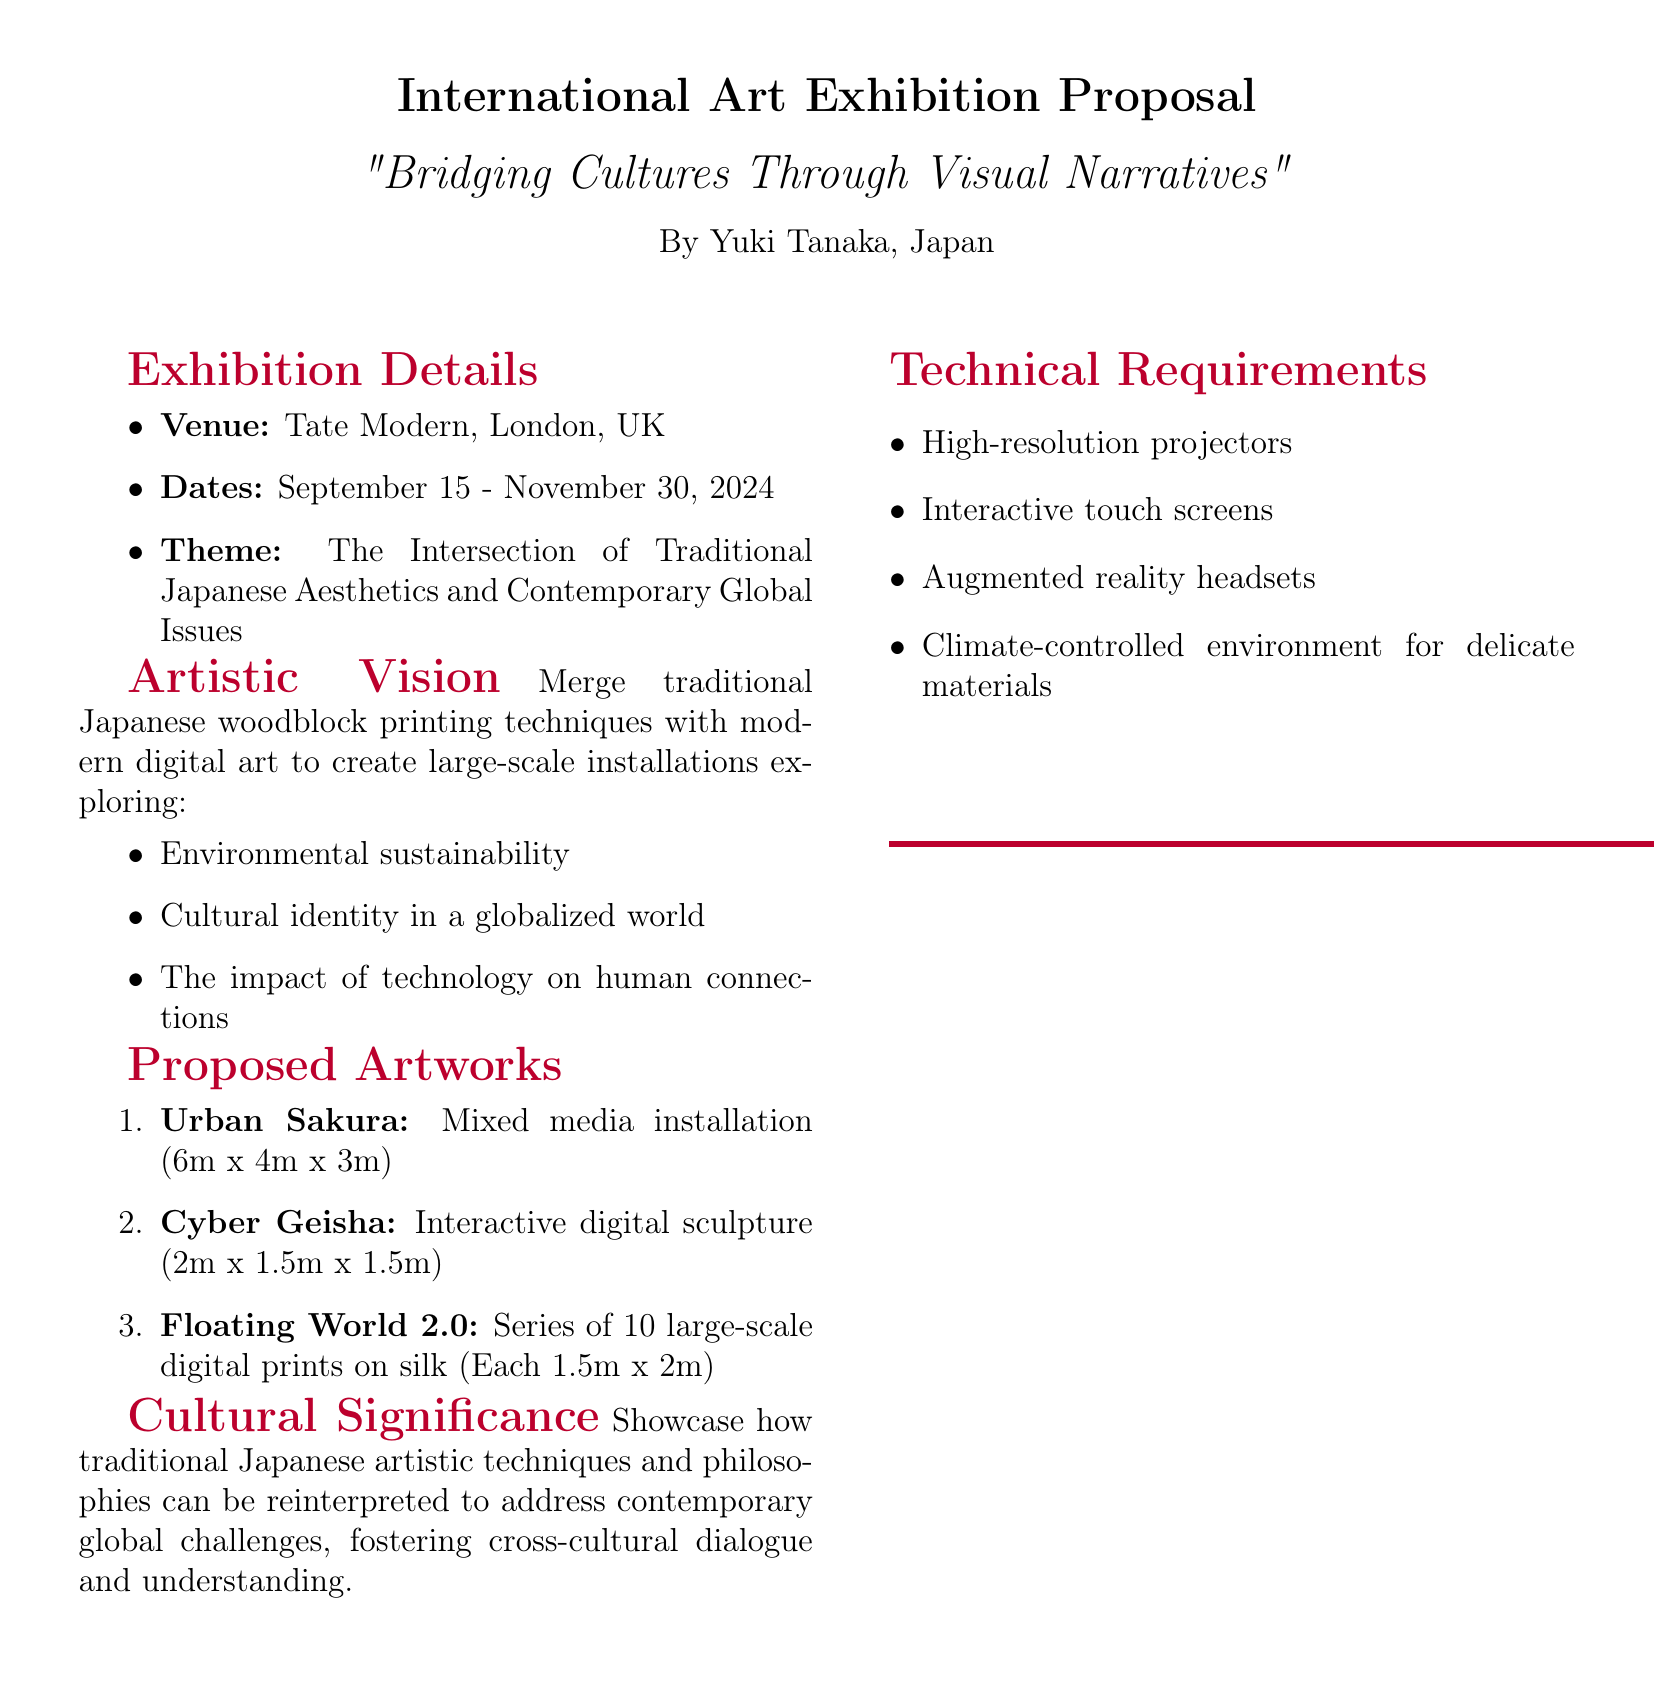What is the title of the exhibition? The title of the exhibition is prominently displayed at the top of the document.
Answer: Bridging Cultures Through Visual Narratives Who is the artist proposing the exhibition? The artist's name appears under the title of the exhibition.
Answer: Yuki Tanaka What are the exhibition dates? The specific dates for the exhibition are listed in the details section.
Answer: September 15 - November 30, 2024 How many artworks are proposed in the exhibition? The number of proposed artworks is mentioned in the list.
Answer: 3 What is one of the themes explored in the artworks? The themes are listed in the artistic vision section.
Answer: Cultural identity in a globalized world What venue will host the exhibition? The venue is stated in the exhibition details section.
Answer: Tate Modern, London, UK What type of installation is "Urban Sakura"? The type of artwork is specified next to its title in the proposed artworks section.
Answer: Mixed media installation What technical requirement is mentioned for the exhibition? Examples of technical requirements are listed in the document.
Answer: High-resolution projectors What artistic technique is integrated with modern digital art? The traditional technique is mentioned in the artistic vision section.
Answer: Japanese woodblock printing 